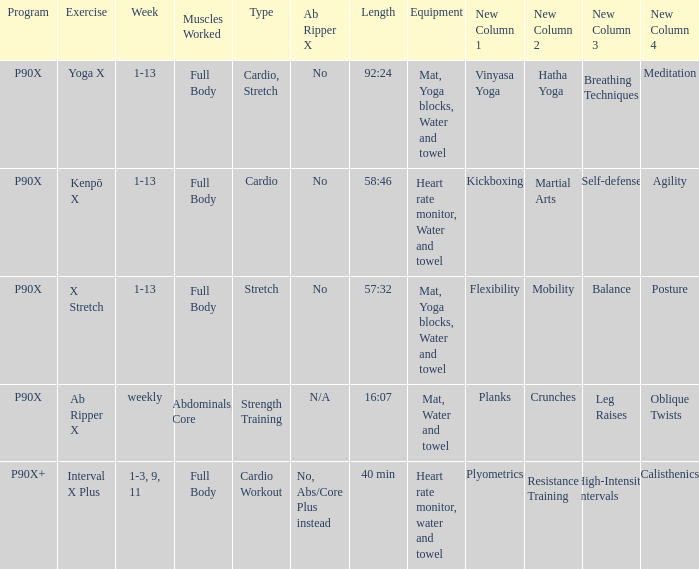Which week is designated for cardio workout type? 1-3, 9, 11. 